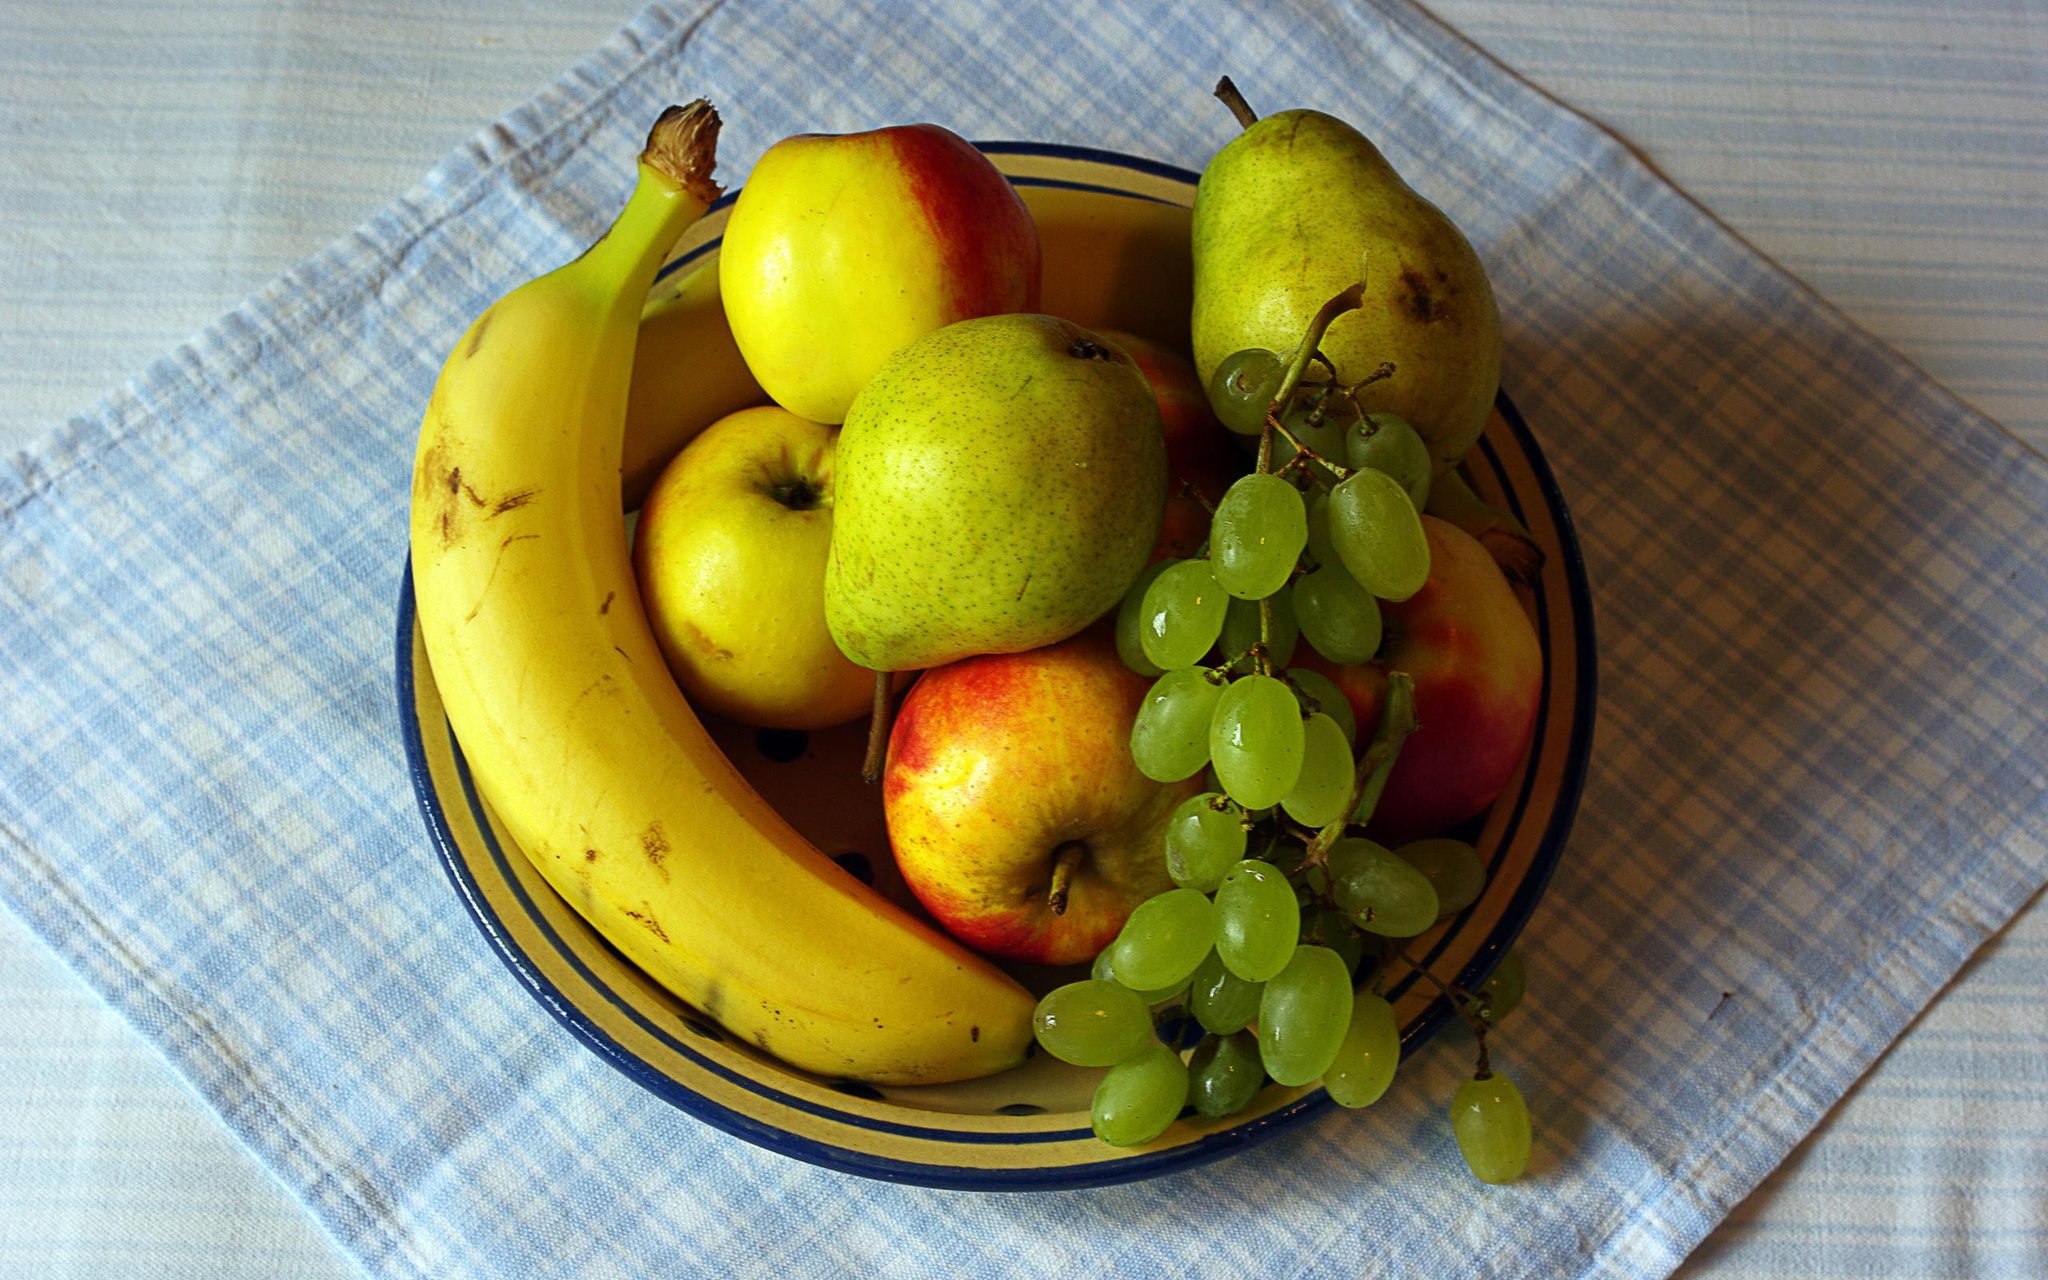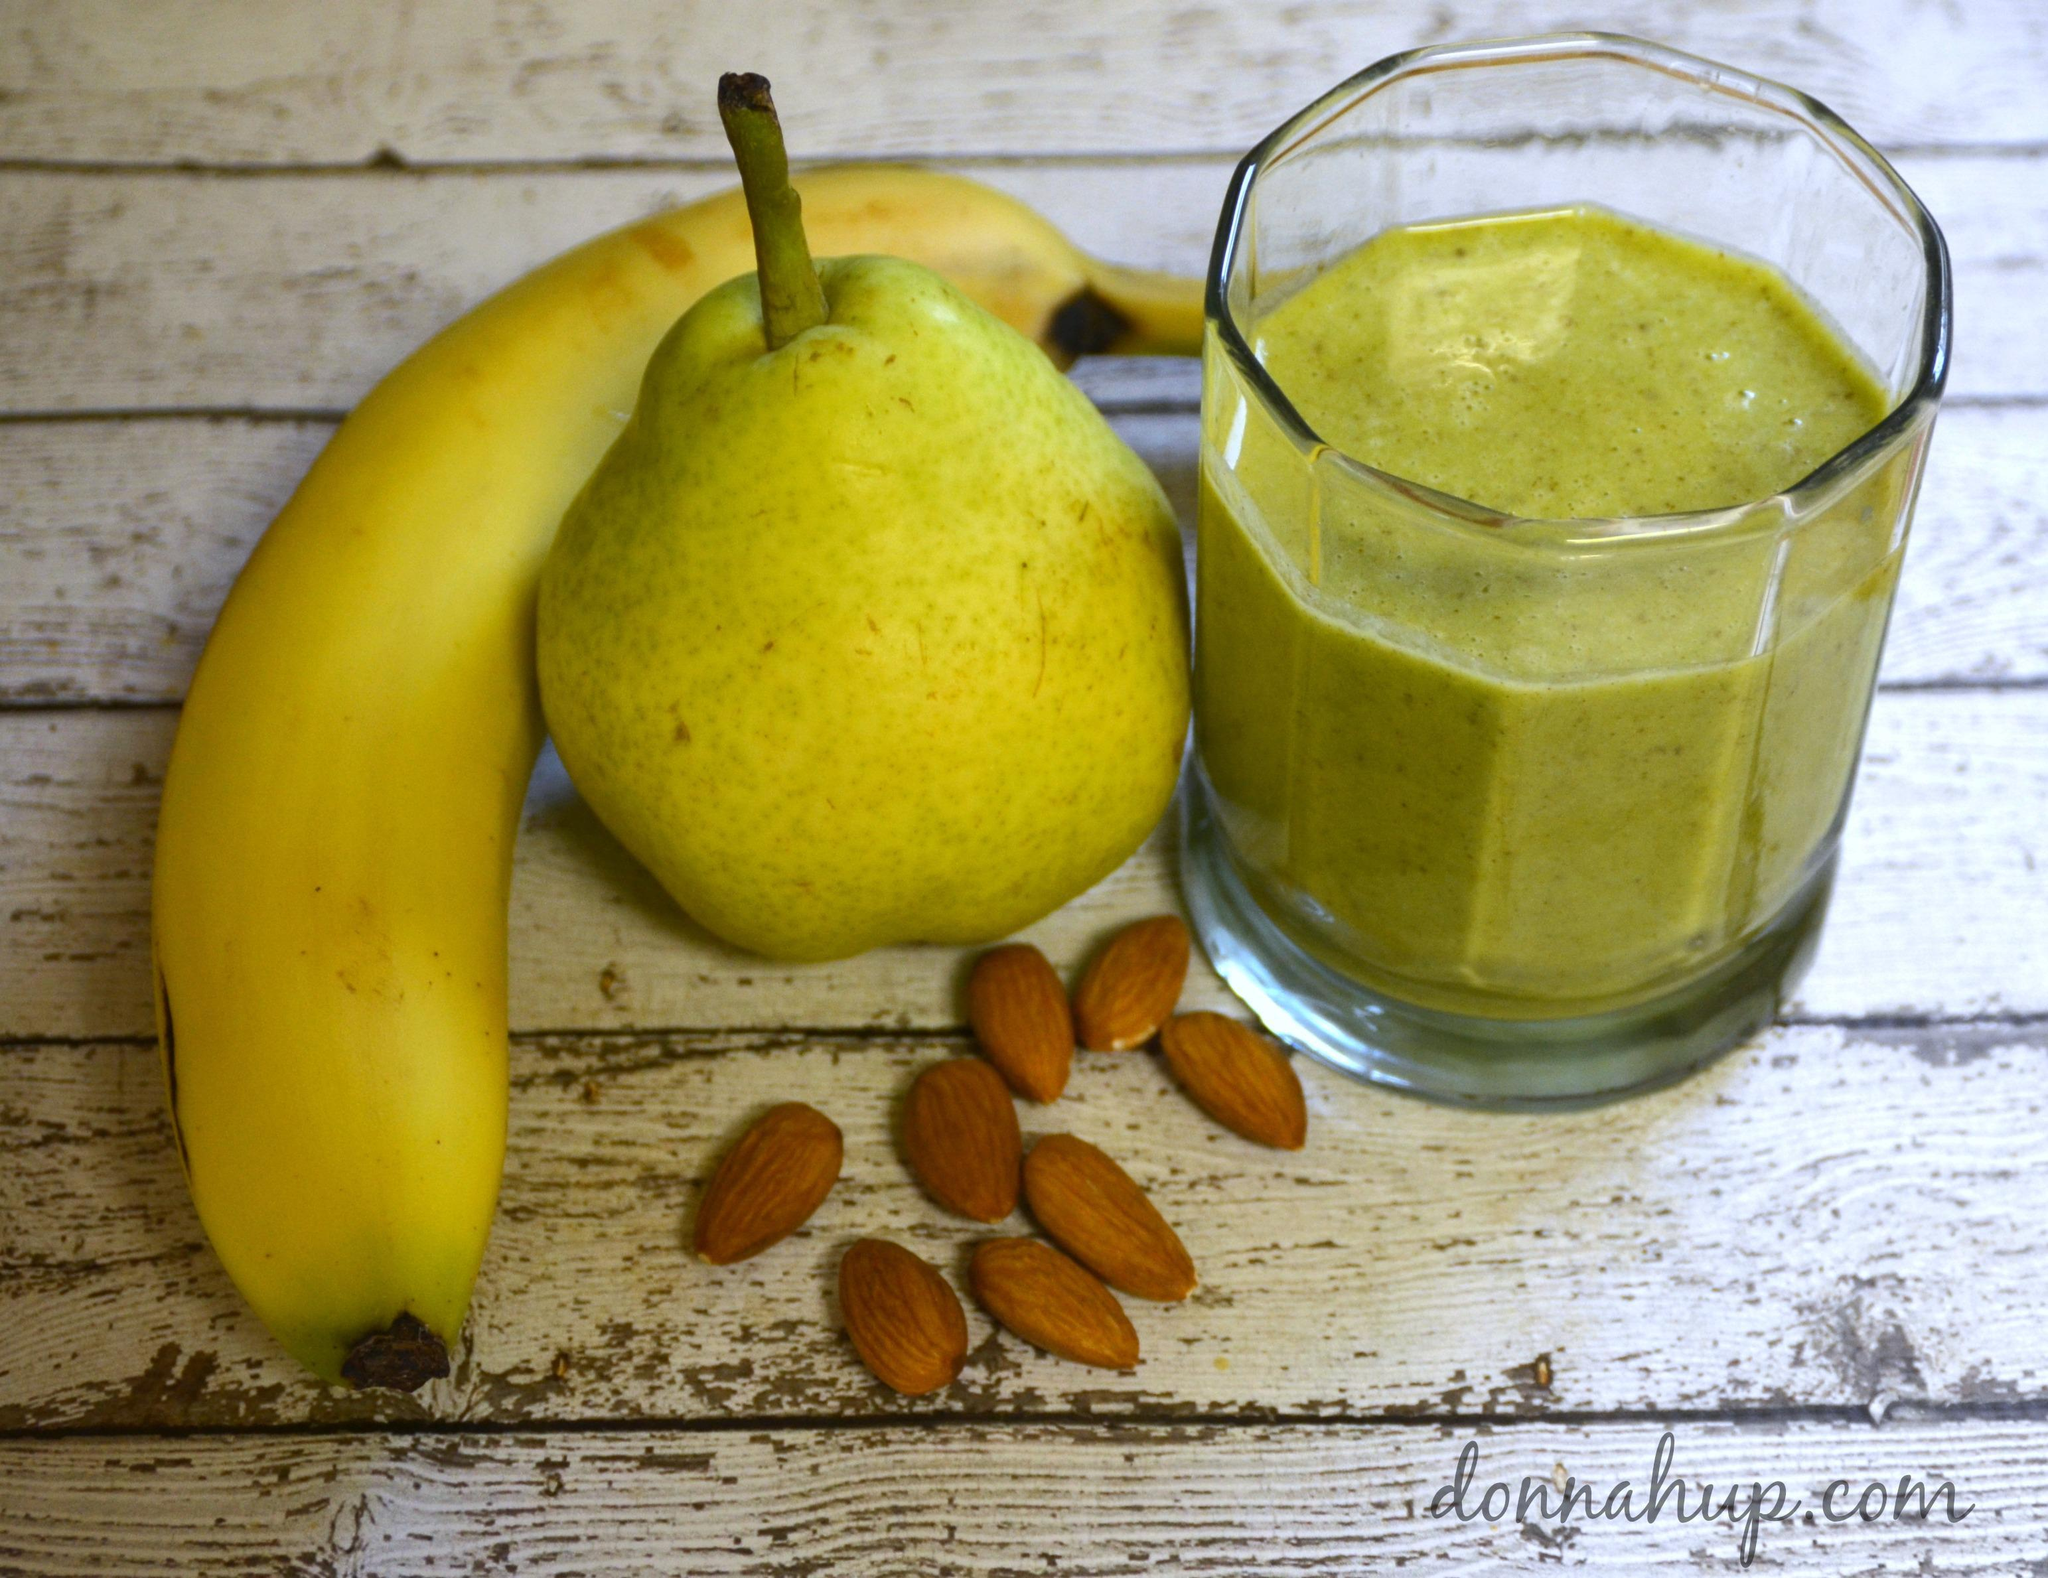The first image is the image on the left, the second image is the image on the right. Assess this claim about the two images: "There are entirely green apples among the fruit in the right image.". Correct or not? Answer yes or no. No. The first image is the image on the left, the second image is the image on the right. Assess this claim about the two images: "An image shows fruit that is not in a container and includes at least one yellow banana and yellow-green pear.". Correct or not? Answer yes or no. Yes. 